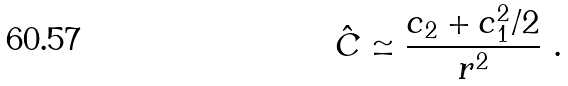<formula> <loc_0><loc_0><loc_500><loc_500>\hat { C } \simeq \frac { c _ { 2 } + c _ { 1 } ^ { 2 } / 2 } { r ^ { 2 } } \ .</formula> 